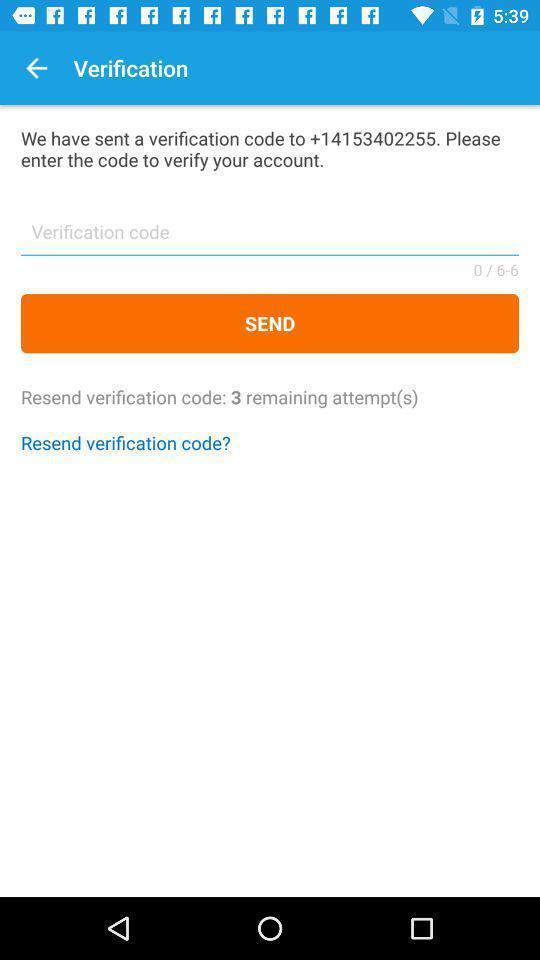Provide a description of this screenshot. Verification page to confirm account. 